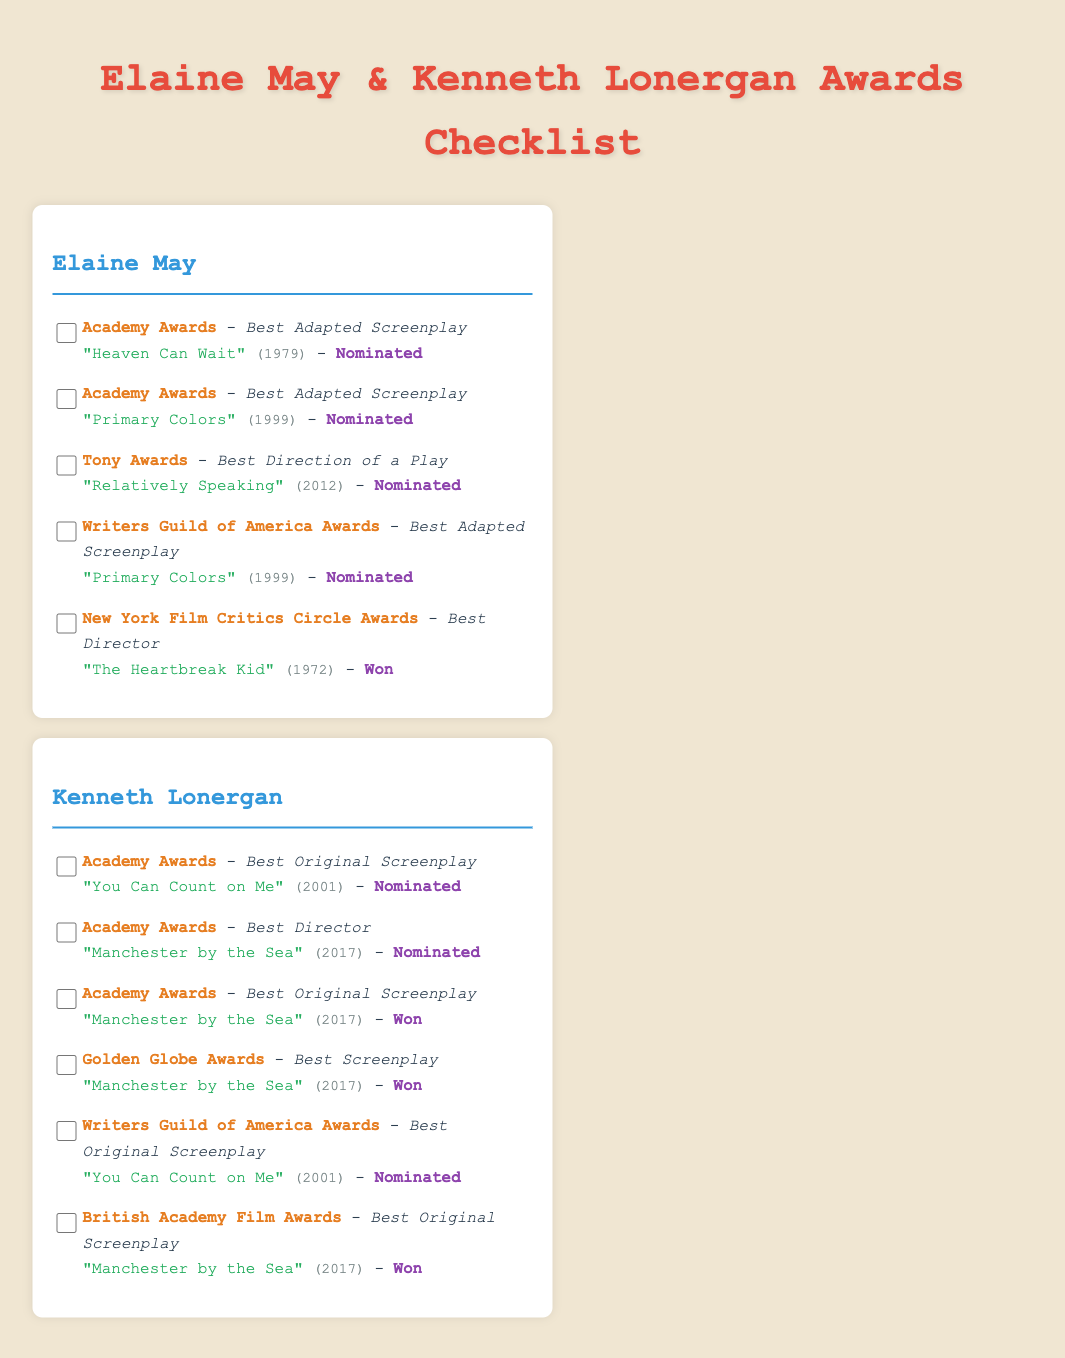What award was Elaine May nominated for in 1979? The document states that Elaine May was nominated for the Academy Awards in the category of Best Adapted Screenplay for "Heaven Can Wait" in 1979.
Answer: Academy Awards How many awards did Kenneth Lonergan win for "Manchester by the Sea"? The document lists two awards that Kenneth Lonergan won for "Manchester by the Sea": one at the Academy Awards and one at the Golden Globe Awards, leading to a total of two wins.
Answer: 2 What is the title of Elaine May's work that won a New York Film Critics Circle Award? According to the document, Elaine May won the New York Film Critics Circle Award for Best Director for "The Heartbreak Kid" in 1972.
Answer: The Heartbreak Kid In which year did Kenneth Lonergan receive a nomination for Best Director at the Academy Awards? The document indicates that Kenneth Lonergan was nominated for Best Director at the Academy Awards for "Manchester by the Sea" in 2017.
Answer: 2017 How many total nominations did Elaine May receive for Best Adapted Screenplay? The document shows that Elaine May was nominated for Best Adapted Screenplay twice: for "Heaven Can Wait" and "Primary Colors".
Answer: 2 What specific category was Kenneth Lonergan nominated for at the Writers Guild of America Awards in 2001? The document details that Kenneth Lonergan was nominated for Best Original Screenplay for "You Can Count on Me" at the Writers Guild of America Awards in 2001.
Answer: Best Original Screenplay What is the status of Elaine May's nomination for Best Direction of a Play at the Tony Awards in 2012? The document states that Elaine May was nominated for the Tony Awards for Best Direction of a Play for "Relatively Speaking" in 2012.
Answer: Nominated Which award category did Kenneth Lonergan win for "Manchester by the Sea" at the British Academy Film Awards? According to the document, Kenneth Lonergan won the category of Best Original Screenplay at the British Academy Film Awards for "Manchester by the Sea".
Answer: Best Original Screenplay 